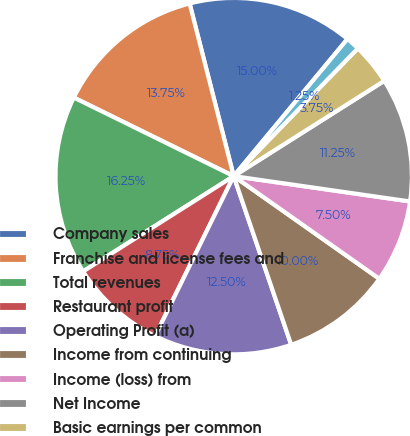Convert chart. <chart><loc_0><loc_0><loc_500><loc_500><pie_chart><fcel>Company sales<fcel>Franchise and license fees and<fcel>Total revenues<fcel>Restaurant profit<fcel>Operating Profit (a)<fcel>Income from continuing<fcel>Income (loss) from<fcel>Net Income<fcel>Basic earnings per common<fcel>Basic earnings(loss) per<nl><fcel>15.0%<fcel>13.75%<fcel>16.25%<fcel>8.75%<fcel>12.5%<fcel>10.0%<fcel>7.5%<fcel>11.25%<fcel>3.75%<fcel>1.25%<nl></chart> 